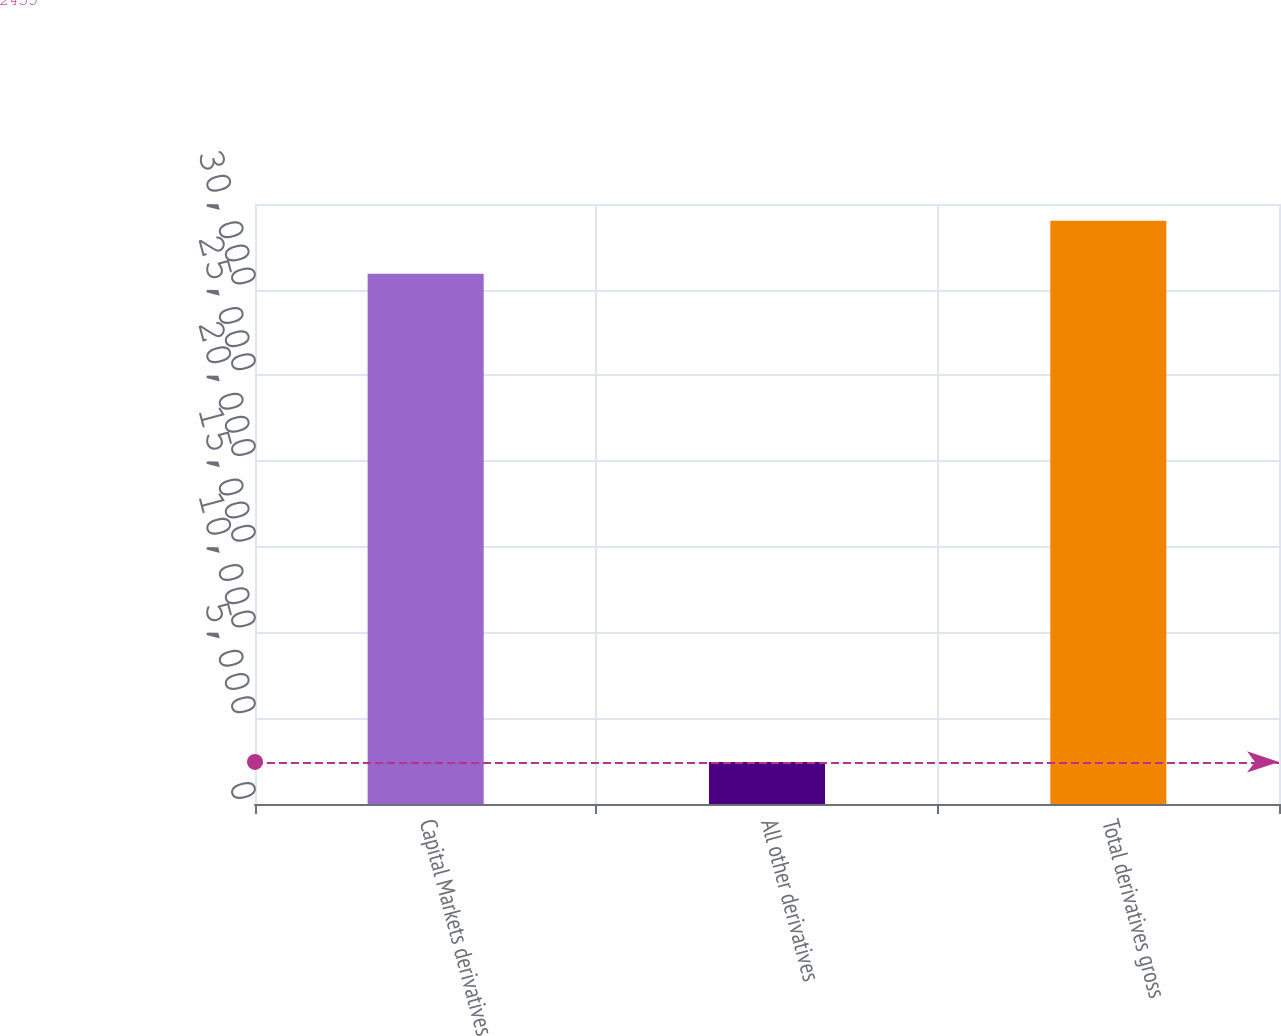Convert chart. <chart><loc_0><loc_0><loc_500><loc_500><bar_chart><fcel>Capital Markets derivatives<fcel>All other derivatives<fcel>Total derivatives gross<nl><fcel>30930<fcel>2455<fcel>34023<nl></chart> 